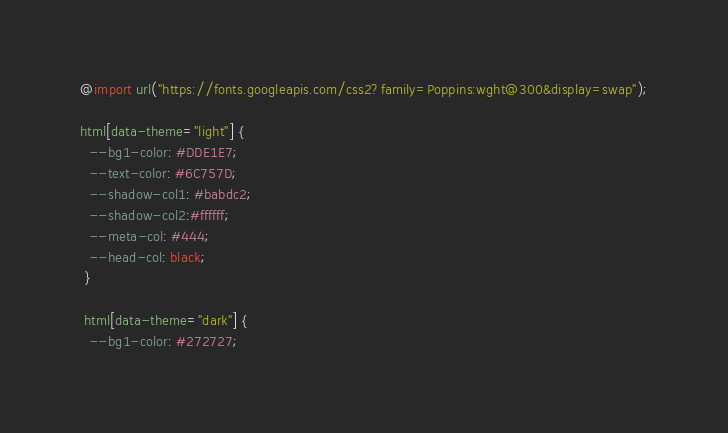Convert code to text. <code><loc_0><loc_0><loc_500><loc_500><_CSS_>@import url("https://fonts.googleapis.com/css2?family=Poppins:wght@300&display=swap");

html[data-theme="light"] {
  --bg1-color: #DDE1E7;
  --text-color: #6C757D;
  --shadow-col1: #babdc2;
  --shadow-col2:#ffffff;
  --meta-col: #444;
  --head-col: black;
 }
 
 html[data-theme="dark"] {
  --bg1-color: #272727;</code> 